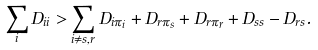<formula> <loc_0><loc_0><loc_500><loc_500>\sum _ { i } D _ { i i } > \sum _ { i \neq s , r } D _ { i \pi _ { i } } + D _ { r \pi _ { s } } + D _ { r \pi _ { r } } + D _ { s s } - D _ { r s } .</formula> 